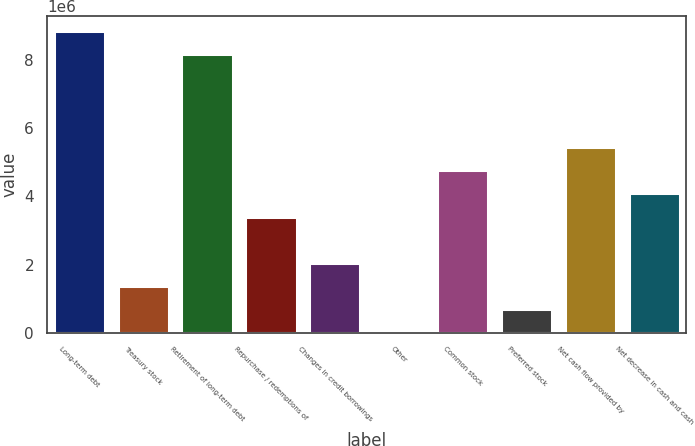<chart> <loc_0><loc_0><loc_500><loc_500><bar_chart><fcel>Long-term debt<fcel>Treasury stock<fcel>Retirement of long-term debt<fcel>Repurchase / redemptions of<fcel>Changes in credit borrowings<fcel>Other<fcel>Common stock<fcel>Preferred stock<fcel>Net cash flow provided by<fcel>Net decrease in cash and cash<nl><fcel>8.83866e+06<fcel>1.36561e+06<fcel>8.1593e+06<fcel>3.40372e+06<fcel>2.04498e+06<fcel>6872<fcel>4.76245e+06<fcel>686241<fcel>5.44182e+06<fcel>4.08308e+06<nl></chart> 